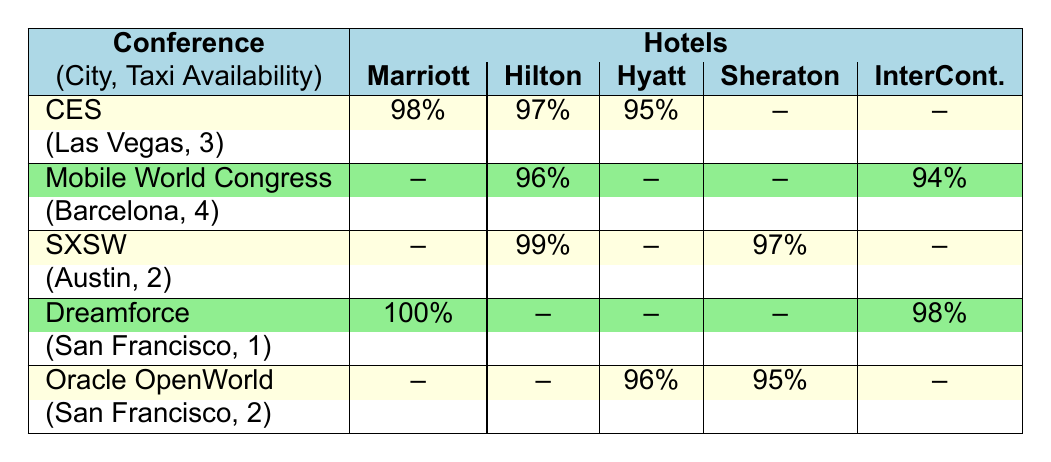What is the highest occupancy rate among the hotels during CES? The table shows that the Marriott Marquis has the highest occupancy rate at 98% during CES.
Answer: 98% Which hotel had an occupancy rate of 99% during SXSW? According to the table, the Hilton Downtown had an occupancy rate of 99% during SXSW.
Answer: Hilton Downtown Is there a hotel listed with a 100% occupancy rate during any conference? Yes, the Marriott Marquis had a 100% occupancy rate during Dreamforce.
Answer: Yes What is the average occupancy rate for the InterContinental hotel? The InterContinental's rates are 94% during Mobile World Congress, 98% during Dreamforce, and no data during other conferences. The average is calculated as (94 + 98) / 2 = 96.
Answer: 96% Which city hosted the conference with the lowest taxi availability? The data shows Dreamforce in San Francisco had the lowest taxi availability with only 1 taxi available.
Answer: San Francisco During which conference did the Hyatt Regency have the highest occupancy rate? The Hyatt Regency had an occupancy rate of 96% during Oracle OpenWorld, which is its only occupancy rate listed in the table, thus it is the highest rate for this hotel.
Answer: Oracle OpenWorld How many hotels had occupancy rates listed for the Mobile World Congress? The table shows two hotels listed for Mobile World Congress: Hilton Downtown (96%) and InterContinental (94%).
Answer: 2 What is the difference in occupancy rates between Hilton Downtown during SXSW and Mobile World Congress? The Hilton Downtown's occupancy rate was 99% during SXSW, while it was 96% during Mobile World Congress. The difference is 99 - 96 = 3%.
Answer: 3% Can you confirm if any hotels became fully booked (100% occupancy) during Oracle OpenWorld? No hotels are listed with a 100% occupancy rate during Oracle OpenWorld; the highest is 96% for Hyatt Regency.
Answer: No Which conference had the highest overall occupancy rates combined from all hotels? Adding up the percentages, CES has a total of 98% + 97% + 95% = 290%, Dreamforce has 100% + 98% = 198%, SXSW has 99% + 97% = 196%, and Oracle OpenWorld has 96% + 95% = 191%. So, CES has the highest overall occupancy rates.
Answer: CES 